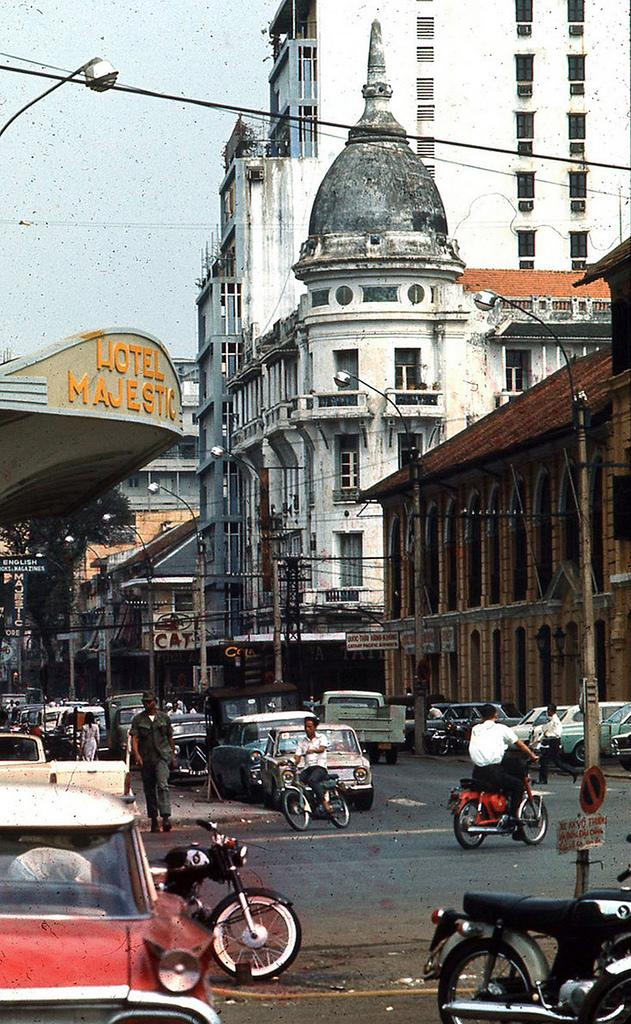What can be seen on the road in the image? There are vehicles and people on the road in the image. What structures are visible in the background? There are buildings visible in the image. What objects can be seen in the image besides vehicles and people? There are poles and trees in the image. Can you tell me how many teeth the girl has in the image? There is no girl present in the image, so it is not possible to determine the number of teeth she might have. 